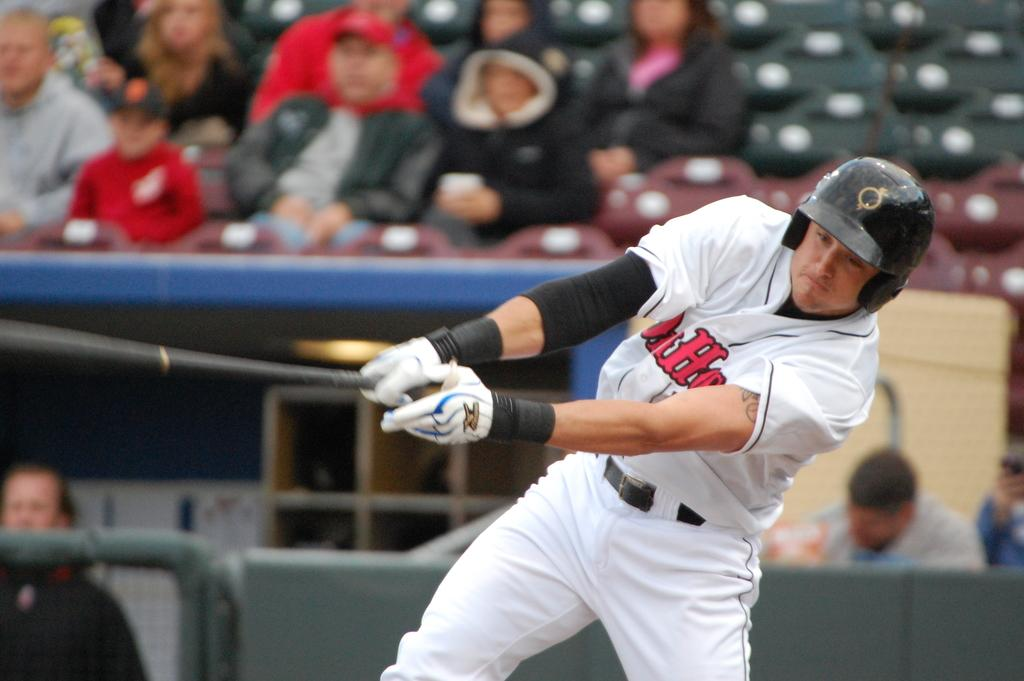<image>
Summarize the visual content of the image. a guy that has the letter H on his jersey 